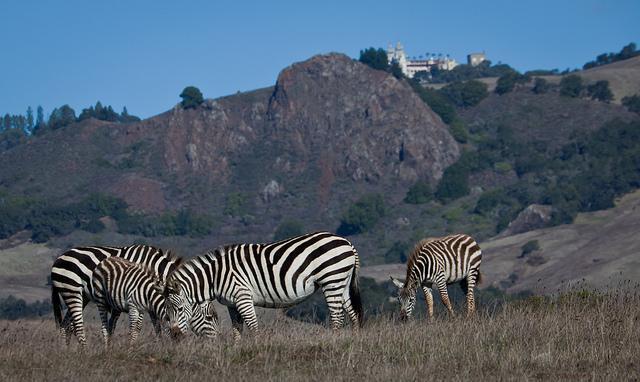How many zebras are there?
Give a very brief answer. 4. 